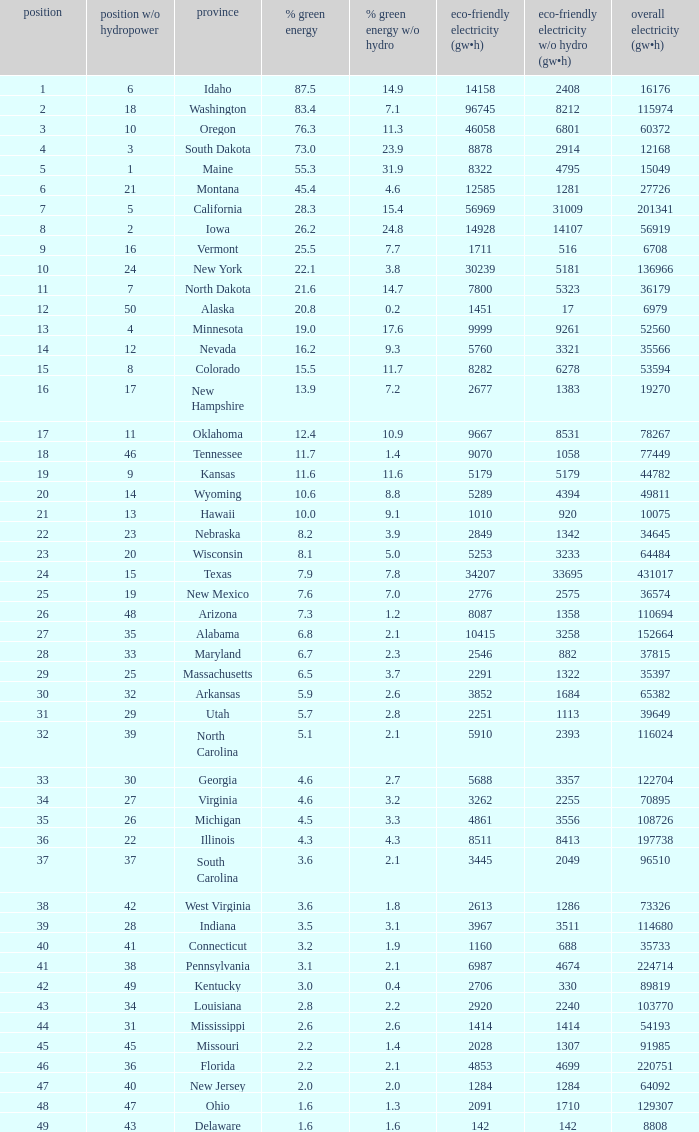Which states have renewable electricity equal to 9667 (gw×h)? Oklahoma. 